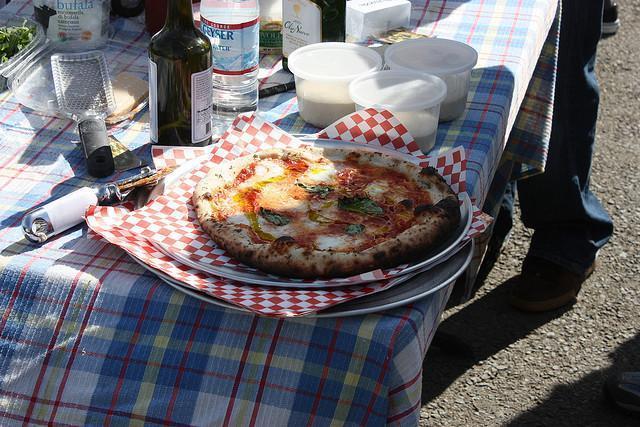How many bowls are in the photo?
Give a very brief answer. 2. How many bottles can you see?
Give a very brief answer. 3. 